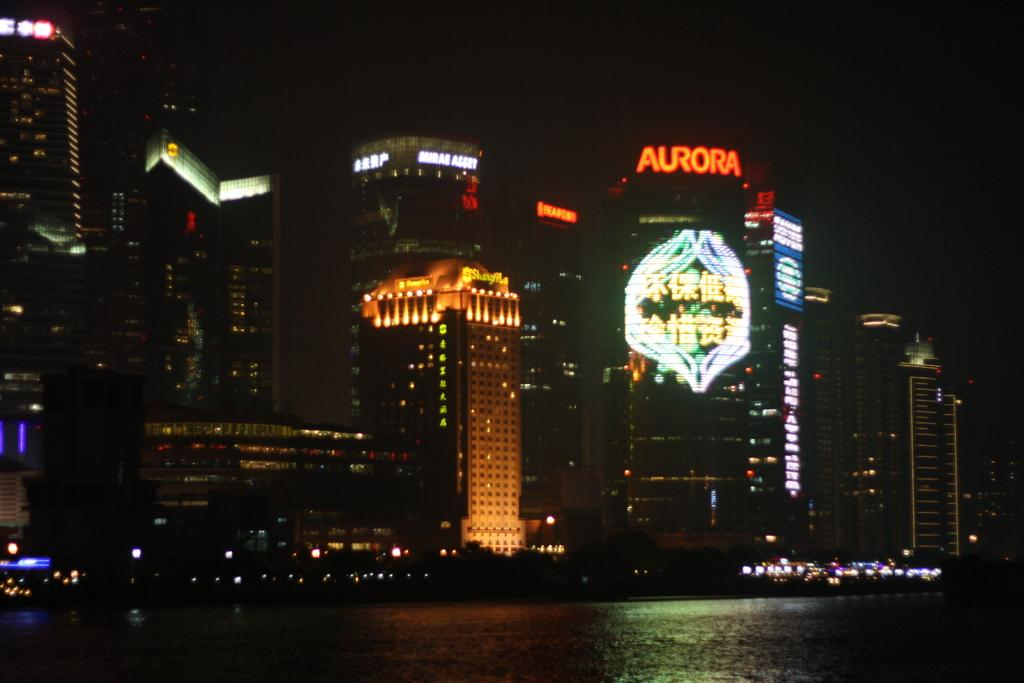What is present in the picture? There is water, buildings, and the sky visible in the background of the picture. Can you describe the water in the picture? The water is a significant part of the image, but no specific details about its appearance or characteristics are provided. What type of structures can be seen in the picture? There are buildings in the picture, but no specific details about their design or purpose are given. What can be seen in the background of the picture? The sky is visible in the background of the picture. What type of cord is used to hold the belief in the picture? There is no mention of a belief or cord in the image; the facts provided only mention water, buildings, and the sky. 